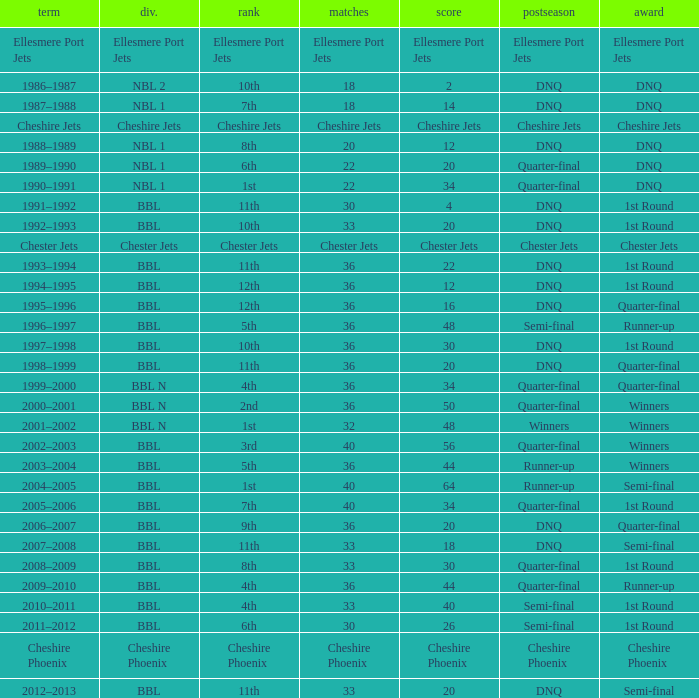I'm looking to parse the entire table for insights. Could you assist me with that? {'header': ['term', 'div.', 'rank', 'matches', 'score', 'postseason', 'award'], 'rows': [['Ellesmere Port Jets', 'Ellesmere Port Jets', 'Ellesmere Port Jets', 'Ellesmere Port Jets', 'Ellesmere Port Jets', 'Ellesmere Port Jets', 'Ellesmere Port Jets'], ['1986–1987', 'NBL 2', '10th', '18', '2', 'DNQ', 'DNQ'], ['1987–1988', 'NBL 1', '7th', '18', '14', 'DNQ', 'DNQ'], ['Cheshire Jets', 'Cheshire Jets', 'Cheshire Jets', 'Cheshire Jets', 'Cheshire Jets', 'Cheshire Jets', 'Cheshire Jets'], ['1988–1989', 'NBL 1', '8th', '20', '12', 'DNQ', 'DNQ'], ['1989–1990', 'NBL 1', '6th', '22', '20', 'Quarter-final', 'DNQ'], ['1990–1991', 'NBL 1', '1st', '22', '34', 'Quarter-final', 'DNQ'], ['1991–1992', 'BBL', '11th', '30', '4', 'DNQ', '1st Round'], ['1992–1993', 'BBL', '10th', '33', '20', 'DNQ', '1st Round'], ['Chester Jets', 'Chester Jets', 'Chester Jets', 'Chester Jets', 'Chester Jets', 'Chester Jets', 'Chester Jets'], ['1993–1994', 'BBL', '11th', '36', '22', 'DNQ', '1st Round'], ['1994–1995', 'BBL', '12th', '36', '12', 'DNQ', '1st Round'], ['1995–1996', 'BBL', '12th', '36', '16', 'DNQ', 'Quarter-final'], ['1996–1997', 'BBL', '5th', '36', '48', 'Semi-final', 'Runner-up'], ['1997–1998', 'BBL', '10th', '36', '30', 'DNQ', '1st Round'], ['1998–1999', 'BBL', '11th', '36', '20', 'DNQ', 'Quarter-final'], ['1999–2000', 'BBL N', '4th', '36', '34', 'Quarter-final', 'Quarter-final'], ['2000–2001', 'BBL N', '2nd', '36', '50', 'Quarter-final', 'Winners'], ['2001–2002', 'BBL N', '1st', '32', '48', 'Winners', 'Winners'], ['2002–2003', 'BBL', '3rd', '40', '56', 'Quarter-final', 'Winners'], ['2003–2004', 'BBL', '5th', '36', '44', 'Runner-up', 'Winners'], ['2004–2005', 'BBL', '1st', '40', '64', 'Runner-up', 'Semi-final'], ['2005–2006', 'BBL', '7th', '40', '34', 'Quarter-final', '1st Round'], ['2006–2007', 'BBL', '9th', '36', '20', 'DNQ', 'Quarter-final'], ['2007–2008', 'BBL', '11th', '33', '18', 'DNQ', 'Semi-final'], ['2008–2009', 'BBL', '8th', '33', '30', 'Quarter-final', '1st Round'], ['2009–2010', 'BBL', '4th', '36', '44', 'Quarter-final', 'Runner-up'], ['2010–2011', 'BBL', '4th', '33', '40', 'Semi-final', '1st Round'], ['2011–2012', 'BBL', '6th', '30', '26', 'Semi-final', '1st Round'], ['Cheshire Phoenix', 'Cheshire Phoenix', 'Cheshire Phoenix', 'Cheshire Phoenix', 'Cheshire Phoenix', 'Cheshire Phoenix', 'Cheshire Phoenix'], ['2012–2013', 'BBL', '11th', '33', '20', 'DNQ', 'Semi-final']]} During the play-off quarter-final which team scored position was the team that scored 56 points? 3rd. 